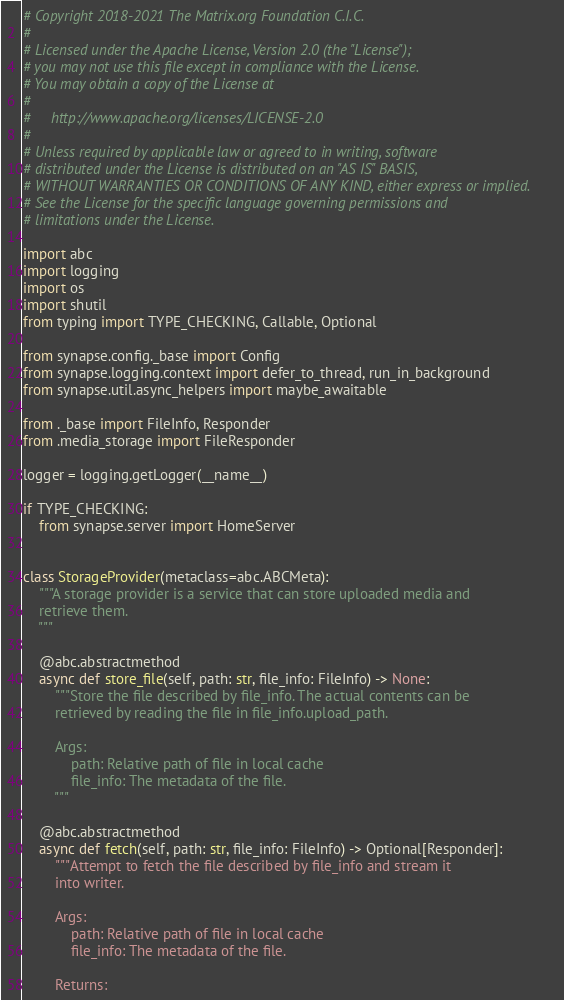Convert code to text. <code><loc_0><loc_0><loc_500><loc_500><_Python_># Copyright 2018-2021 The Matrix.org Foundation C.I.C.
#
# Licensed under the Apache License, Version 2.0 (the "License");
# you may not use this file except in compliance with the License.
# You may obtain a copy of the License at
#
#     http://www.apache.org/licenses/LICENSE-2.0
#
# Unless required by applicable law or agreed to in writing, software
# distributed under the License is distributed on an "AS IS" BASIS,
# WITHOUT WARRANTIES OR CONDITIONS OF ANY KIND, either express or implied.
# See the License for the specific language governing permissions and
# limitations under the License.

import abc
import logging
import os
import shutil
from typing import TYPE_CHECKING, Callable, Optional

from synapse.config._base import Config
from synapse.logging.context import defer_to_thread, run_in_background
from synapse.util.async_helpers import maybe_awaitable

from ._base import FileInfo, Responder
from .media_storage import FileResponder

logger = logging.getLogger(__name__)

if TYPE_CHECKING:
    from synapse.server import HomeServer


class StorageProvider(metaclass=abc.ABCMeta):
    """A storage provider is a service that can store uploaded media and
    retrieve them.
    """

    @abc.abstractmethod
    async def store_file(self, path: str, file_info: FileInfo) -> None:
        """Store the file described by file_info. The actual contents can be
        retrieved by reading the file in file_info.upload_path.

        Args:
            path: Relative path of file in local cache
            file_info: The metadata of the file.
        """

    @abc.abstractmethod
    async def fetch(self, path: str, file_info: FileInfo) -> Optional[Responder]:
        """Attempt to fetch the file described by file_info and stream it
        into writer.

        Args:
            path: Relative path of file in local cache
            file_info: The metadata of the file.

        Returns:</code> 